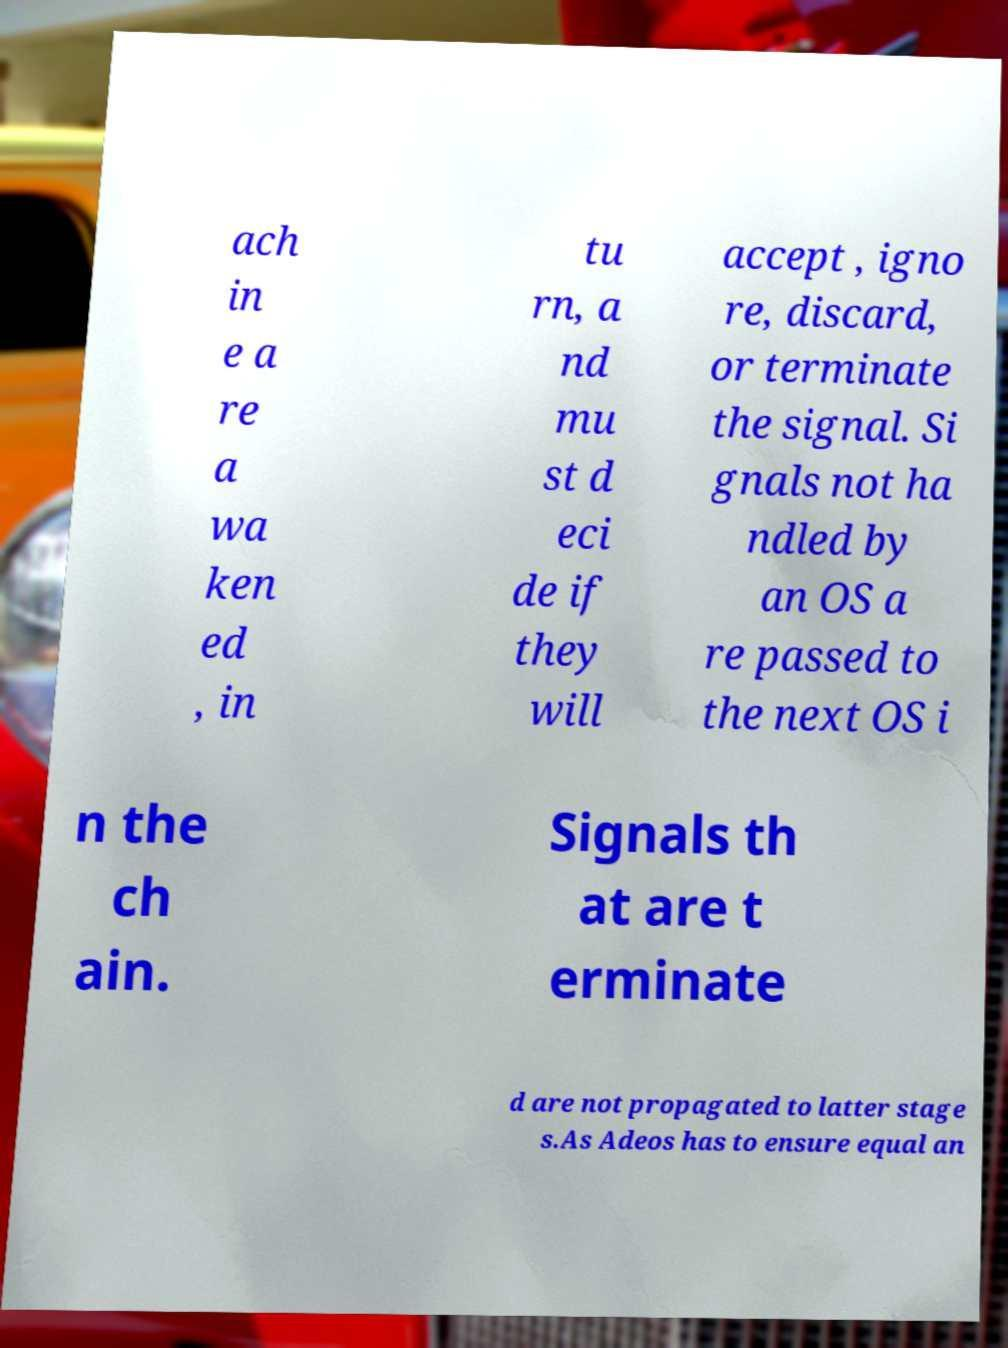For documentation purposes, I need the text within this image transcribed. Could you provide that? ach in e a re a wa ken ed , in tu rn, a nd mu st d eci de if they will accept , igno re, discard, or terminate the signal. Si gnals not ha ndled by an OS a re passed to the next OS i n the ch ain. Signals th at are t erminate d are not propagated to latter stage s.As Adeos has to ensure equal an 